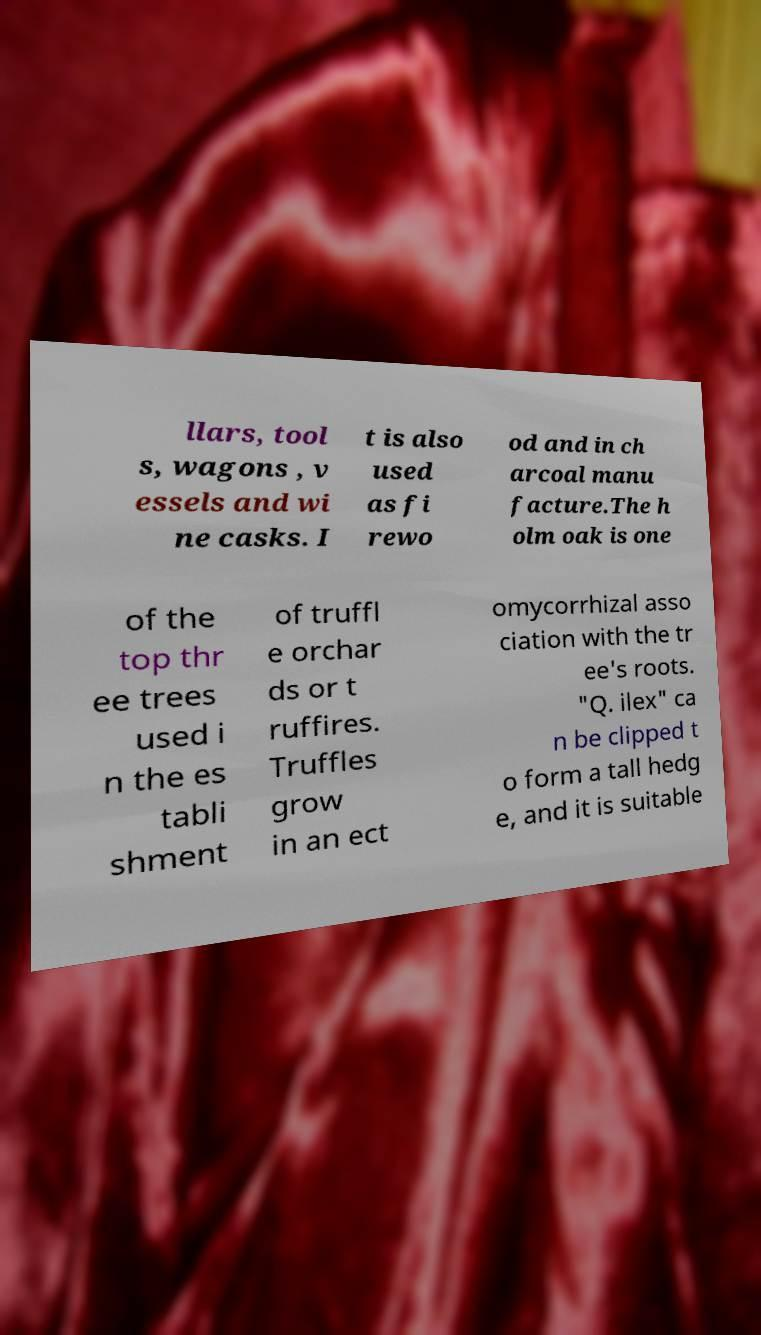For documentation purposes, I need the text within this image transcribed. Could you provide that? llars, tool s, wagons , v essels and wi ne casks. I t is also used as fi rewo od and in ch arcoal manu facture.The h olm oak is one of the top thr ee trees used i n the es tabli shment of truffl e orchar ds or t ruffires. Truffles grow in an ect omycorrhizal asso ciation with the tr ee's roots. "Q. ilex" ca n be clipped t o form a tall hedg e, and it is suitable 